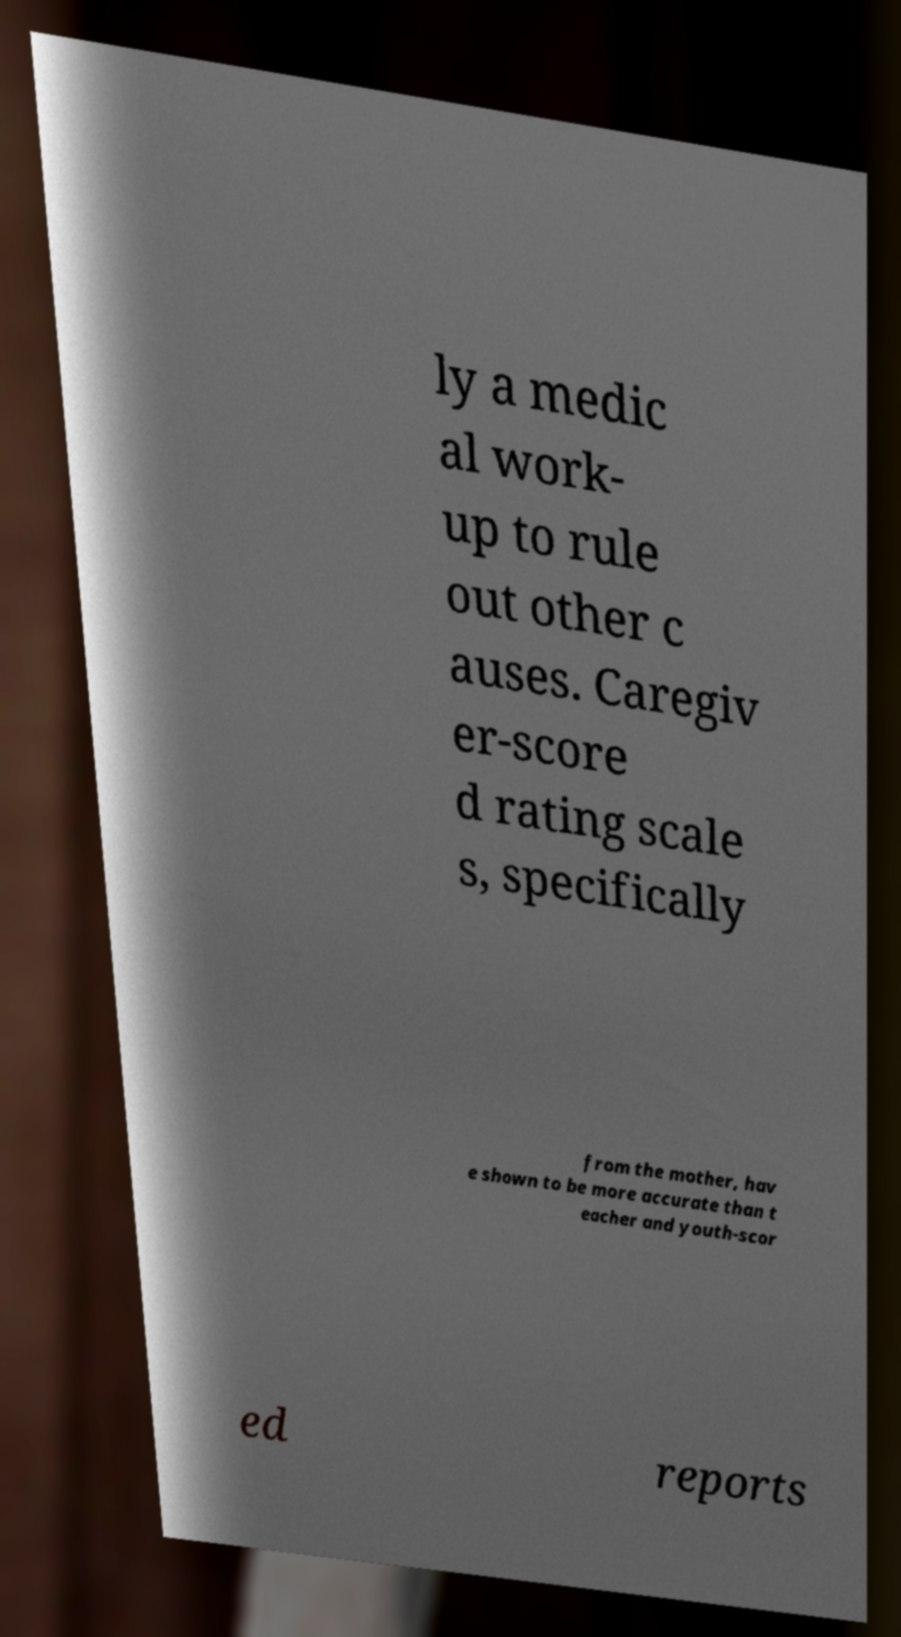I need the written content from this picture converted into text. Can you do that? ly a medic al work- up to rule out other c auses. Caregiv er-score d rating scale s, specifically from the mother, hav e shown to be more accurate than t eacher and youth-scor ed reports 